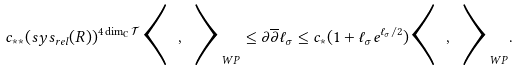Convert formula to latex. <formula><loc_0><loc_0><loc_500><loc_500>c _ { * * } ( s y s _ { r e l } ( R ) ) ^ { 4 \dim _ { \mathbb { C } } \mathcal { T } } \Big < \ , \ \Big > _ { W P } \leq \partial \overline { \partial } \ell _ { \sigma } \leq c _ { * } ( 1 + \ell _ { \sigma } e ^ { \ell _ { \sigma } / 2 } ) \Big < \ , \ \Big > _ { W P } .</formula> 